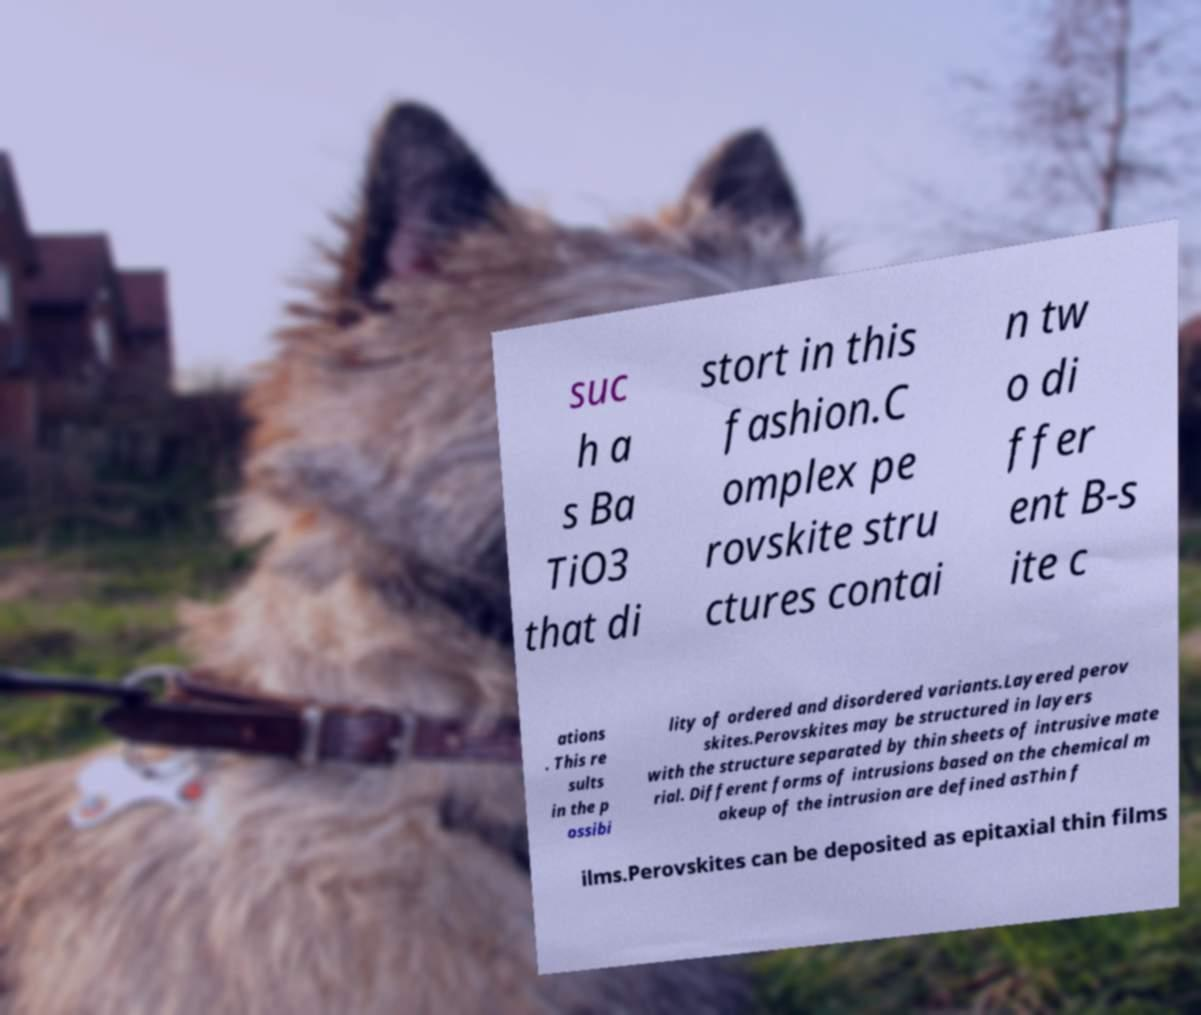For documentation purposes, I need the text within this image transcribed. Could you provide that? suc h a s Ba TiO3 that di stort in this fashion.C omplex pe rovskite stru ctures contai n tw o di ffer ent B-s ite c ations . This re sults in the p ossibi lity of ordered and disordered variants.Layered perov skites.Perovskites may be structured in layers with the structure separated by thin sheets of intrusive mate rial. Different forms of intrusions based on the chemical m akeup of the intrusion are defined asThin f ilms.Perovskites can be deposited as epitaxial thin films 